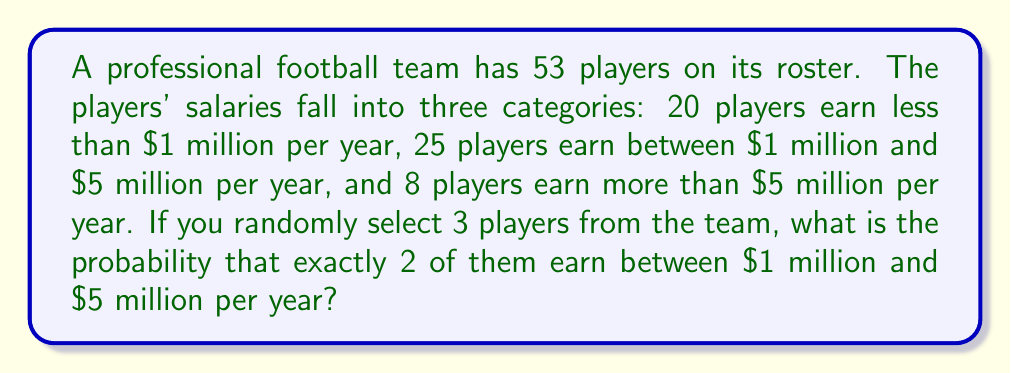Help me with this question. Let's approach this step-by-step using the concept of combinations:

1) First, we need to calculate the number of ways to select 3 players out of 53:
   $${53 \choose 3} = \frac{53!}{3!(53-3)!} = \frac{53!}{3!50!} = 23426$$

2) Now, we need to calculate the number of ways to select exactly 2 players earning between $1M and $5M, and 1 player from the other categories:

   a) Select 2 out of 25 players earning $1M-$5M:
      $${25 \choose 2} = \frac{25!}{2!23!} = 300$$

   b) Select 1 out of the remaining 28 players (20 + 8):
      $${28 \choose 1} = 28$$

3) Multiply these together to get the total number of favorable outcomes:
   $$300 * 28 = 8400$$

4) The probability is then:
   $$P(\text{exactly 2 earning \$1M-\$5M}) = \frac{\text{favorable outcomes}}{\text{total outcomes}} = \frac{8400}{23426}$$

5) Simplify the fraction:
   $$\frac{8400}{23426} = \frac{300}{837} \approx 0.3585$$
Answer: $\frac{300}{837}$ 